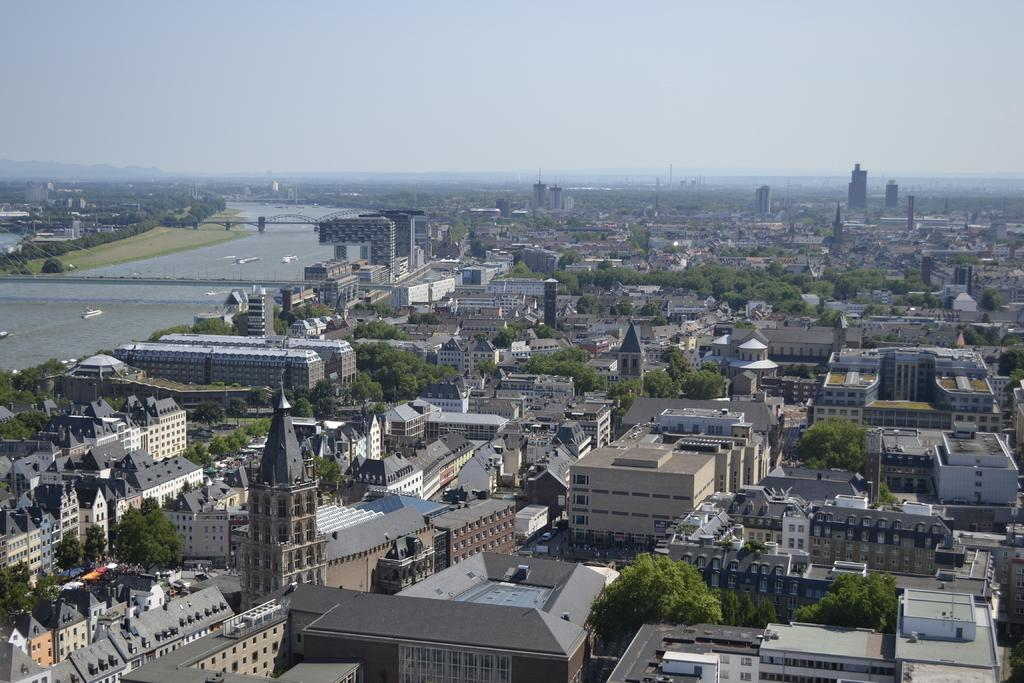What body of water is present in the image? There is a lake in the picture. What structure can be seen on the lake? There is a bridge on the lake. What type of structures are visible in the image? There are many buildings in the picture. What type of vegetation is present in the image? There are trees in the picture. What is the condition of the sky in the image? The sky is clear in the image. How many apples are hanging from the trees in the image? There are no apples present in the image; it only features trees. What type of house can be seen in the image? There is no house present in the image; it only features buildings and trees. 